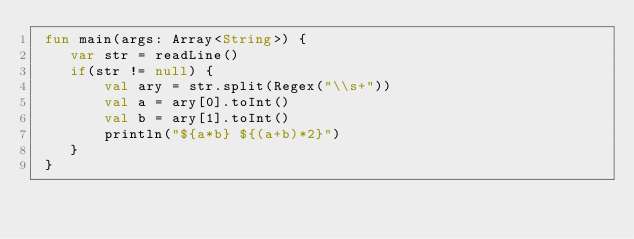<code> <loc_0><loc_0><loc_500><loc_500><_Kotlin_> fun main(args: Array<String>) {
    var str = readLine()
    if(str != null) {
        val ary = str.split(Regex("\\s+"))
        val a = ary[0].toInt()
        val b = ary[1].toInt()
        println("${a*b} ${(a+b)*2}")
    }
 }
</code> 